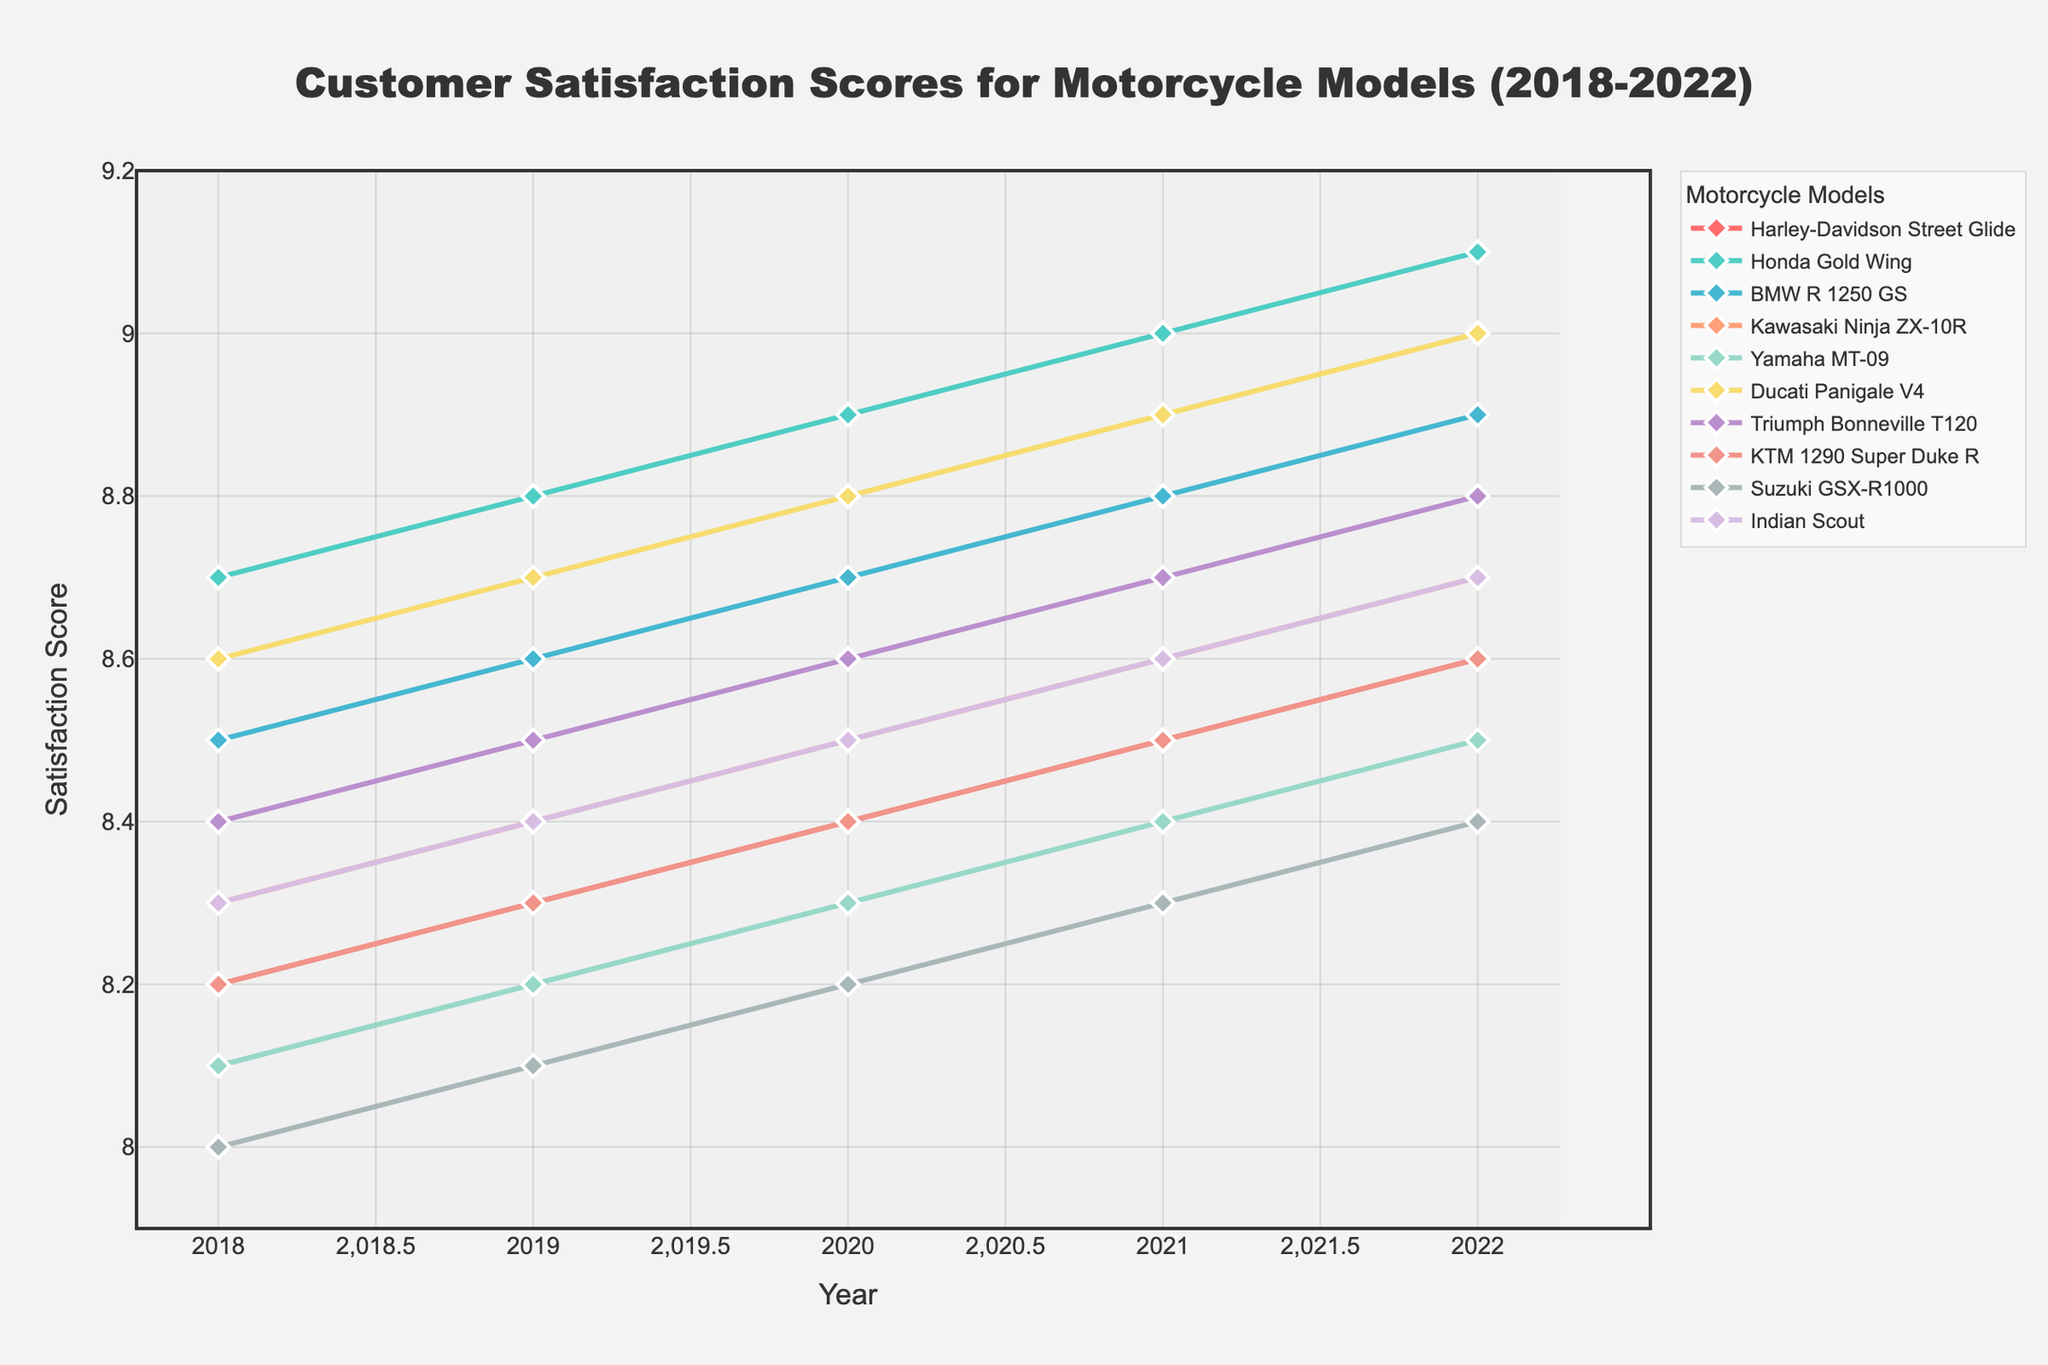What's the average satisfaction score for the Harley-Davidson Street Glide over the 5 years? First, sum the satisfaction scores for each year: 8.2 + 8.3 + 8.4 + 8.5 + 8.6 = 42. Next, divide by the number of years, which is 5: 42 / 5 = 8.4
Answer: 8.4 Which model had the highest satisfaction score in 2018? Look at the scores for each model in 2018 and find the highest value: 8.7 (Honda Gold Wing)
Answer: Honda Gold Wing Which two models have the closest satisfaction scores in 2021? Compare the satisfaction scores for each model in 2021 and find the closest values: Harley-Davidson Street Glide (8.5) and KTM 1290 Super Duke R (8.5)
Answer: Harley-Davidson Street Glide, KTM 1290 Super Duke R Has the satisfaction score for the Yamaha MT-09 consistently increased over the years? Look at the satisfaction scores for the Yamaha MT-09 from 2018 to 2022: 8.1, 8.2, 8.3, 8.4, 8.5. Since the score increases each year, it has consistently increased
Answer: Yes What is the difference in the satisfaction score of the Ducati Panigale V4 between 2018 and 2022? Subtract the 2018 score from the 2022 score for the Ducati Panigale V4: 9.0 - 8.6 = 0.4
Answer: 0.4 Which model showed the greatest improvement in satisfaction score over the 5-year period? Calculate the difference between the 2022 score and the 2018 score for each model. Honda Gold Wing: 9.1-8.7=0.4, Harley-Davidson Street Glide: 8.6-8.2=0.4, BMW R 1250 GS: 8.9-8.5=0.4, Kawasaki Ninja ZX-10R: 8.7-8.3=0.4, Yamaha MT-09: 8.5-8.1=0.4, Ducati Panigale V4: 9.0-8.6=0.4, Triumph Bonneville T120: 8.8-8.4=0.4, KTM 1290 Super Duke R: 8.6-8.2=0.4, Suzuki GSX-R1000: 8.4-8.0=0.4, Indian Scout: 8.7-8.3=0.4. All models show the same improvement of 0.4
Answer: All models (0.4) Which model had the lowest satisfaction score in 2022? Look at the scores for each model in 2022 and find the lowest value: 8.4 (Suzuki GSX-R1000)
Answer: Suzuki GSX-R1000 How does the satisfaction score trend of the BMW R 1250 GS compare to the Honda Gold Wing from 2018 to 2022? Look at the scores for both models from 2018 to 2022. BMW R 1250 GS: 8.5, 8.6, 8.7, 8.8, 8.9 (steady increase). Honda Gold Wing: 8.7, 8.8, 8.9, 9.0, 9.1 (steady increase). Both show a steady increase over the years
Answer: Both show a steady increase What is the average satisfaction score across all models for the year 2020? First, sum the 2020 scores for all models: 8.4 + 8.9 + 8.7 + 8.5 + 8.3 + 8.8 + 8.6 + 8.4 + 8.2 + 8.5 = 84.3. Then, divide by the number of models, which is 10: 84.3 / 10 = 8.43
Answer: 8.43 